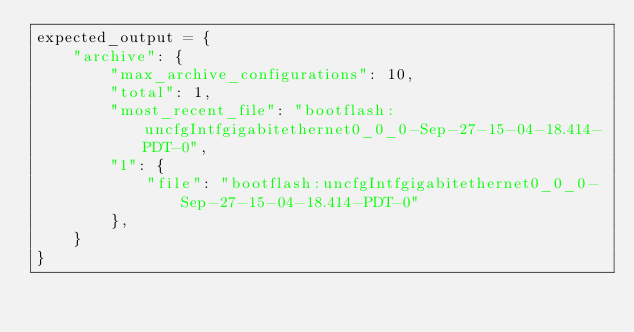Convert code to text. <code><loc_0><loc_0><loc_500><loc_500><_Python_>expected_output = {
    "archive": {
        "max_archive_configurations": 10,
        "total": 1,
        "most_recent_file": "bootflash:uncfgIntfgigabitethernet0_0_0-Sep-27-15-04-18.414-PDT-0",
        "1": {
            "file": "bootflash:uncfgIntfgigabitethernet0_0_0-Sep-27-15-04-18.414-PDT-0"
        },
    }
}
</code> 